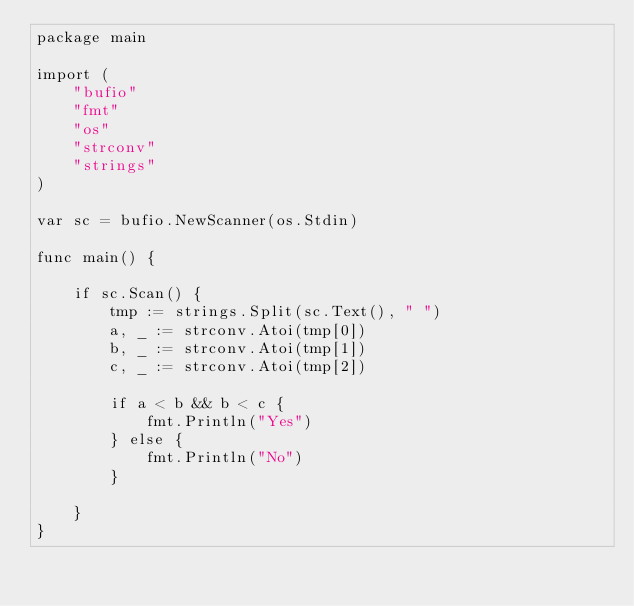<code> <loc_0><loc_0><loc_500><loc_500><_Go_>package main

import (
	"bufio"
	"fmt"
	"os"
	"strconv"
	"strings"
)

var sc = bufio.NewScanner(os.Stdin)

func main() {

	if sc.Scan() {
		tmp := strings.Split(sc.Text(), " ")
		a, _ := strconv.Atoi(tmp[0])
		b, _ := strconv.Atoi(tmp[1])
		c, _ := strconv.Atoi(tmp[2])

		if a < b && b < c {
			fmt.Println("Yes")
		} else {
			fmt.Println("No")
		}

	}
}

</code> 